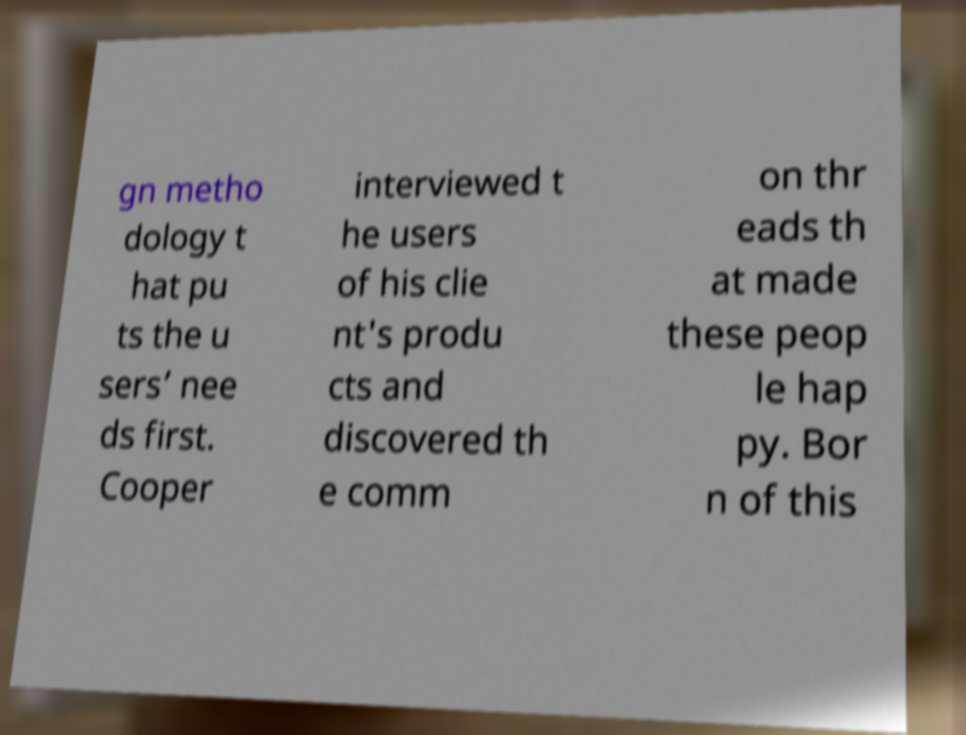What messages or text are displayed in this image? I need them in a readable, typed format. gn metho dology t hat pu ts the u sers’ nee ds first. Cooper interviewed t he users of his clie nt's produ cts and discovered th e comm on thr eads th at made these peop le hap py. Bor n of this 